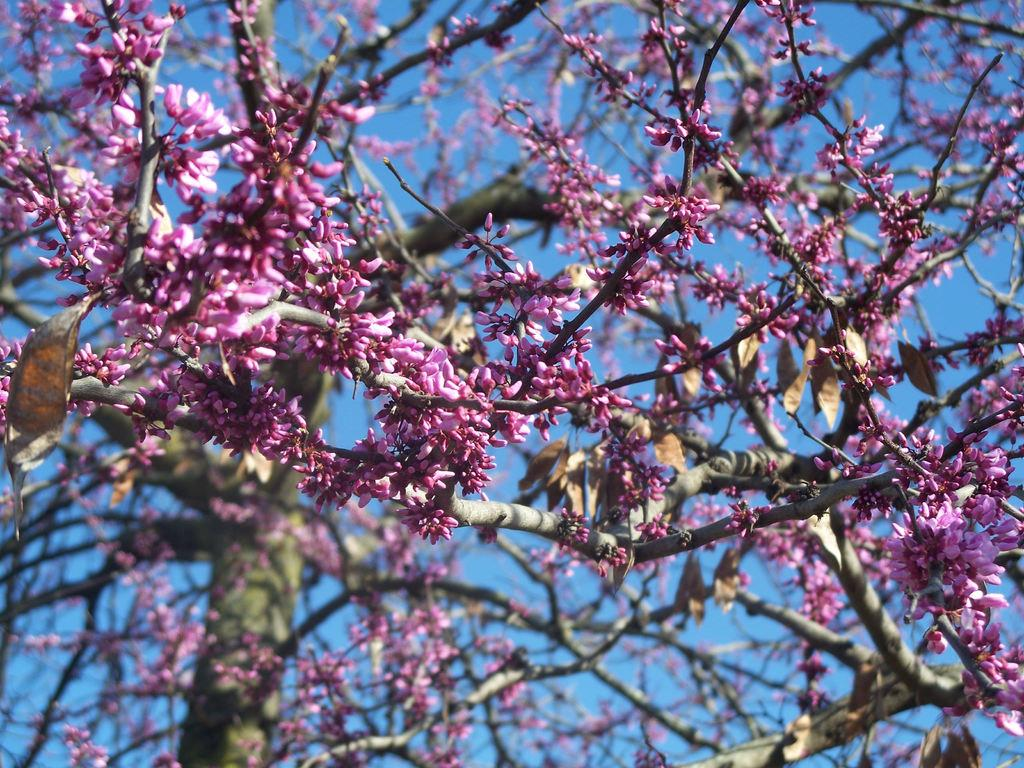What type of tree is present in the image? There is a tree with pink color flowers in the image. How much of the tree is visible in the image? The tree is partially visible in the image. What part of the natural environment can be seen in the image? A part of the sky is visible in the image. How many firemen are climbing the tree in the image? There are no firemen present in the image; it features a tree with pink flowers. What type of ship can be seen sailing in the background of the image? There is no ship visible in the image; it only shows a tree with pink flowers and a part of the sky. 